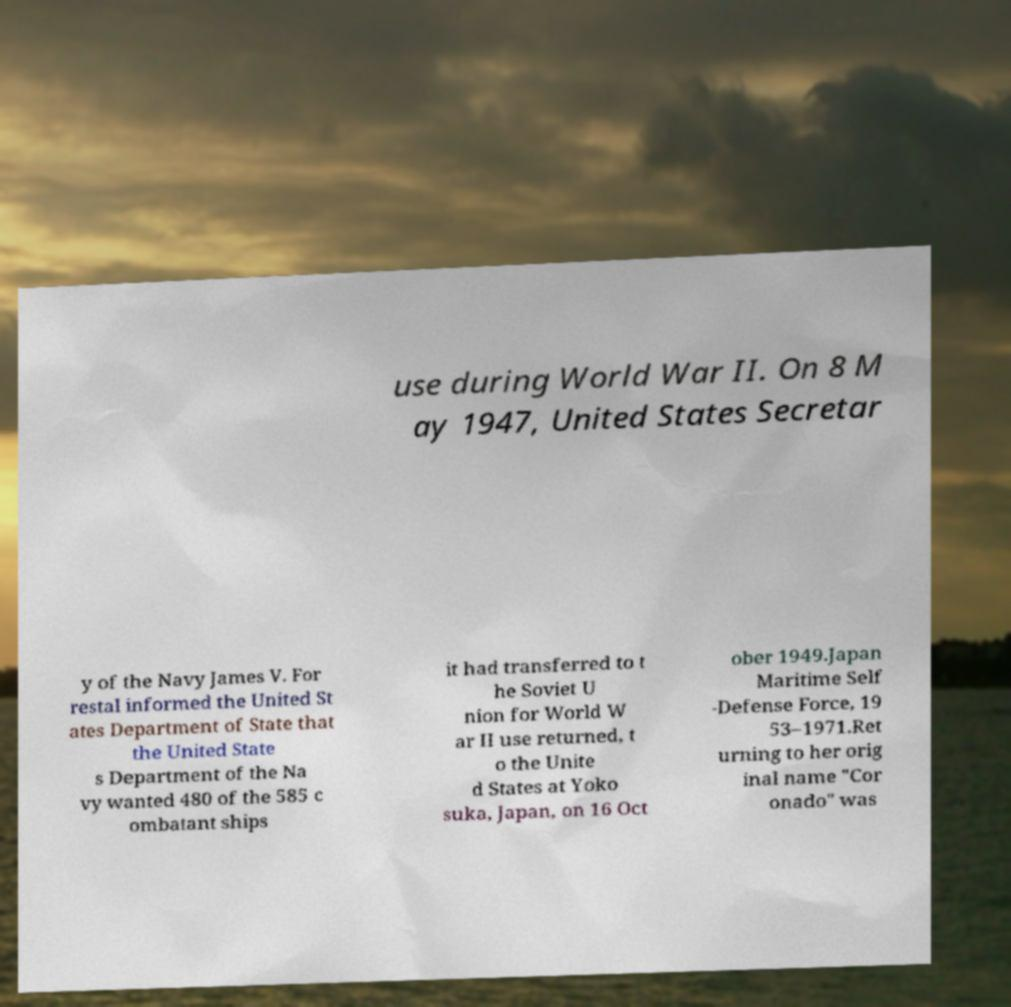Can you read and provide the text displayed in the image?This photo seems to have some interesting text. Can you extract and type it out for me? use during World War II. On 8 M ay 1947, United States Secretar y of the Navy James V. For restal informed the United St ates Department of State that the United State s Department of the Na vy wanted 480 of the 585 c ombatant ships it had transferred to t he Soviet U nion for World W ar II use returned, t o the Unite d States at Yoko suka, Japan, on 16 Oct ober 1949.Japan Maritime Self -Defense Force, 19 53–1971.Ret urning to her orig inal name "Cor onado" was 